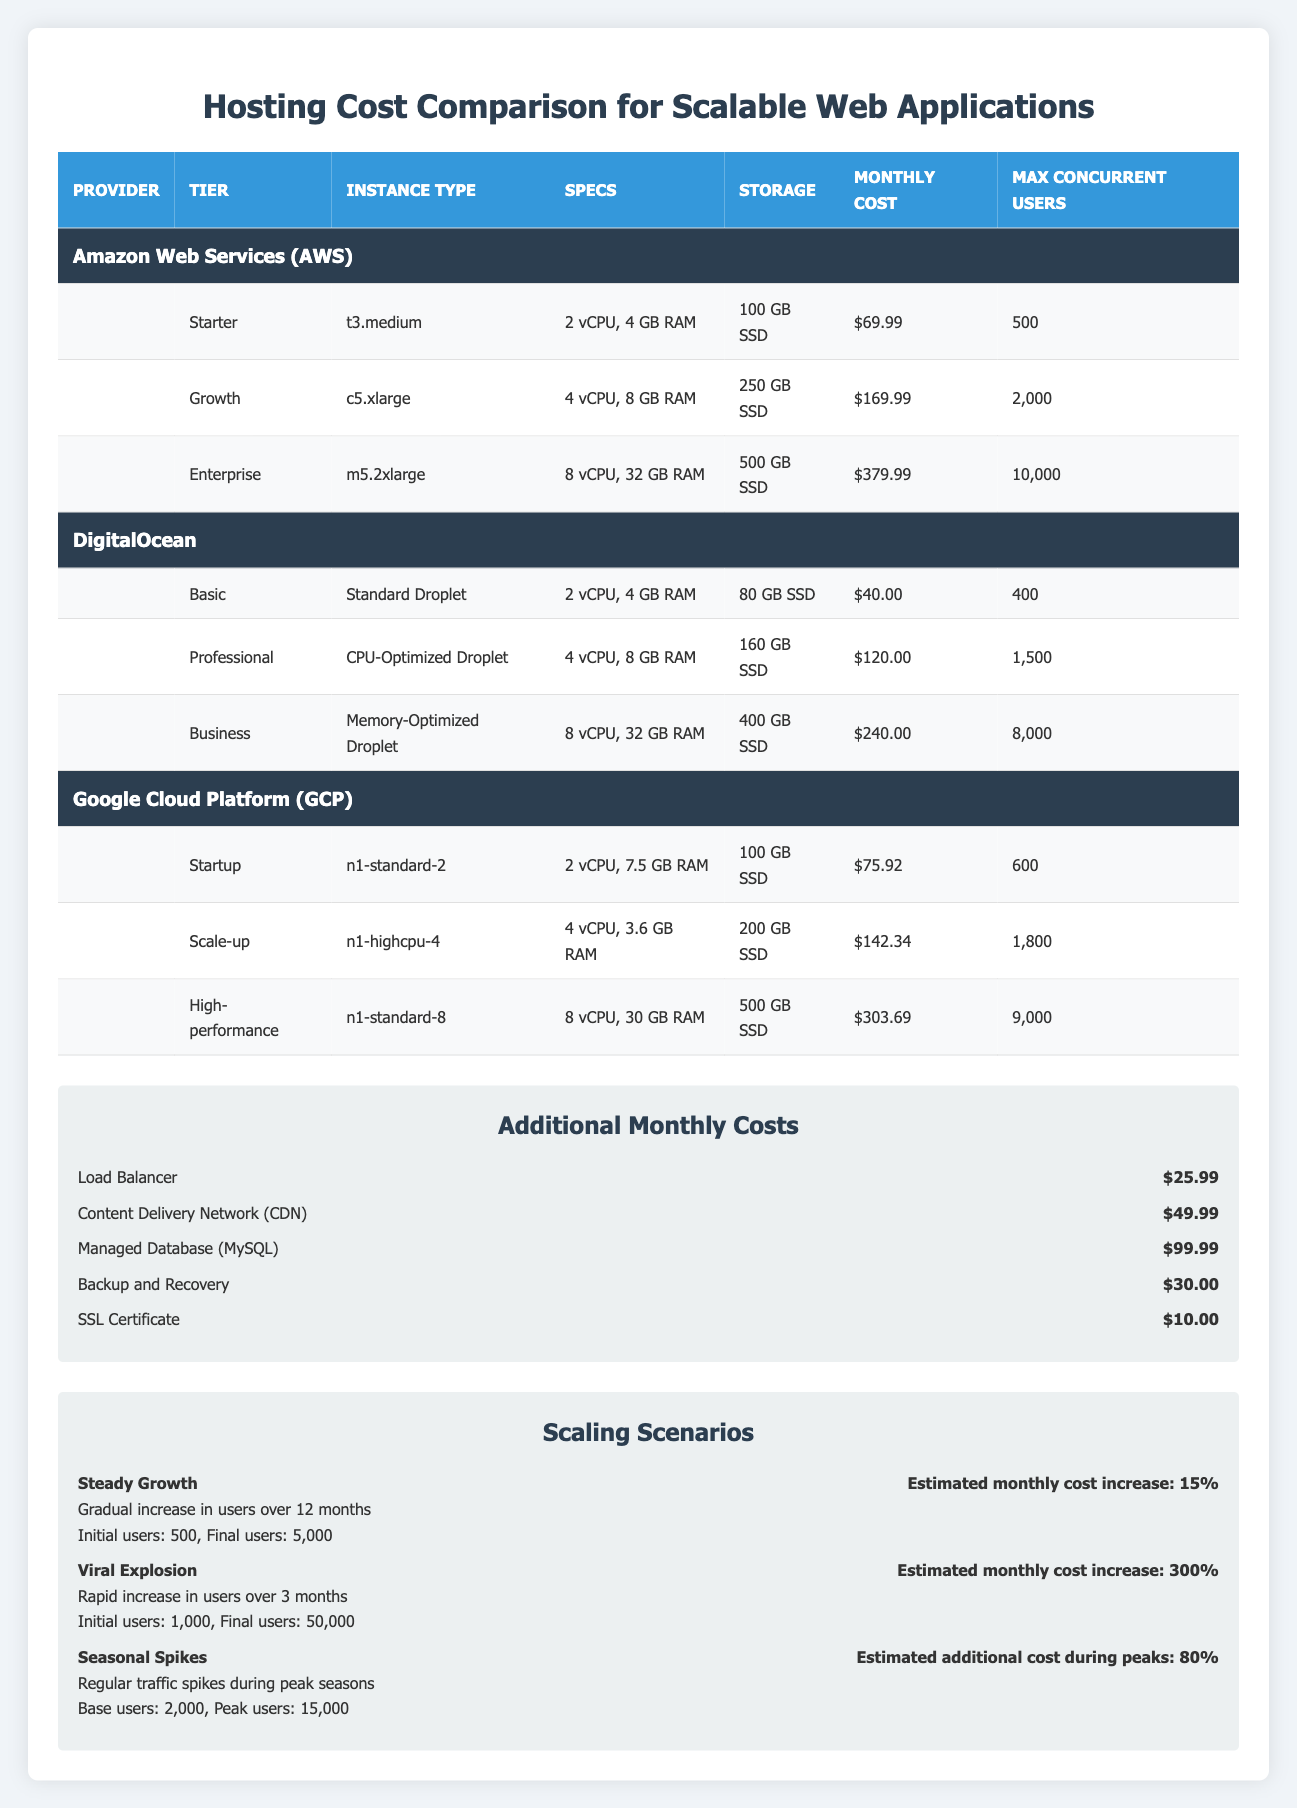What is the monthly cost for the Basic tier on DigitalOcean? The Basic tier on DigitalOcean has a monthly cost listed in the table. By locating the row for the Basic tier under the DigitalOcean provider, we can see that the cost is $40.00.
Answer: 40.00 Which hosting provider offers the highest monthly cost for their highest tier? To find out which hosting provider has the highest monthly cost for their top tier, we compare the monthly costs for the Enterprise tier of AWS ($379.99), the Business tier of DigitalOcean ($240.00), and the High-performance tier of GCP ($303.69). The Enterprise tier of AWS at $379.99 is the highest.
Answer: AWS at $379.99 How much RAM does the Growth tier on AWS provide? The RAM for the Growth tier on AWS can be found in the table under the corresponding row. This tier specifies that it has 8 GB of RAM.
Answer: 8 GB If a company selects the High-performance tier from GCP, what would be the total estimated monthly cost including all additional services? The High-performance tier from GCP costs $303.69. Then, we'll add the costs of the additional services: Load Balancer ($25.99), CDN ($49.99), Managed Database ($99.99), Backup and Recovery ($30.00), and SSL Certificate ($10.00). Summing these amounts gives us: $303.69 + $25.99 + $49.99 + $99.99 + $30.00 + $10.00 = $519.66.
Answer: 519.66 Is there a tier with a maximum concurrent user capacity of 2,000 or more? Looking for a tier with a maximum concurrent user capacity of 2,000 or more leads us to check the max concurrent users column. The Growth tier of AWS has a capacity of 2,000 users, as well as the Enterprise tier which can handle 10,000 users. Thus, the answer is yes.
Answer: Yes What is the difference in monthly cost between the Professional tier at DigitalOcean and the Scale-up tier at GCP? To find the difference in cost, first retrieve the costs from the table: the Professional tier at DigitalOcean is $120.00, and the Scale-up tier at GCP is $142.34. We then calculate: $142.34 - $120.00 = $22.34.
Answer: 22.34 Which tier has the lowest storage capacity, and what is that capacity? We look through the storage capacity listed for each tier across all providers. The Basic tier of DigitalOcean has the lowest storage at 80 GB SSD. Therefore, it is the one with the lowest capacity.
Answer: 80 GB SSD What is the estimated additional cost during peak times for the Seasonal Spikes scenario? In the Seasonal Spikes scenario from the table, the estimated additional cost during peak user times is specified as 80%. There is no specific dollar amount given for the increase.
Answer: 80% 